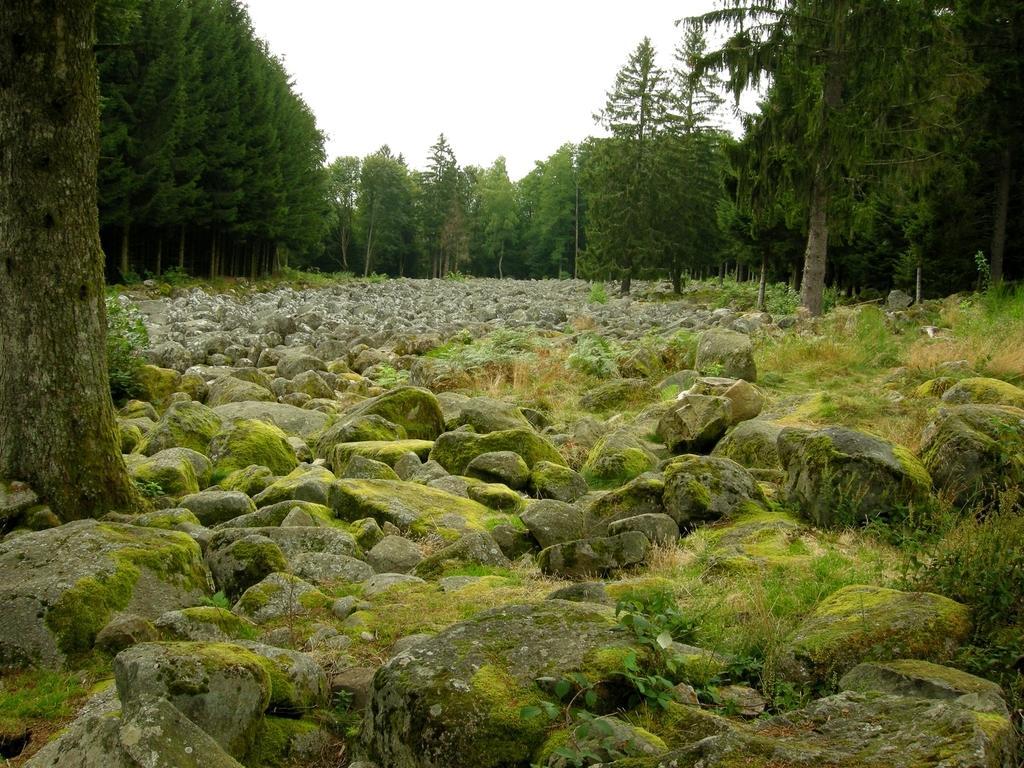In one or two sentences, can you explain what this image depicts? At the bottom, we see stones or the rocks which are covered with the green algae. On the left side, we see the stem of the tree. In the middle, we see the stones or rocks. There are trees in the background. At the top, we see the sky. 